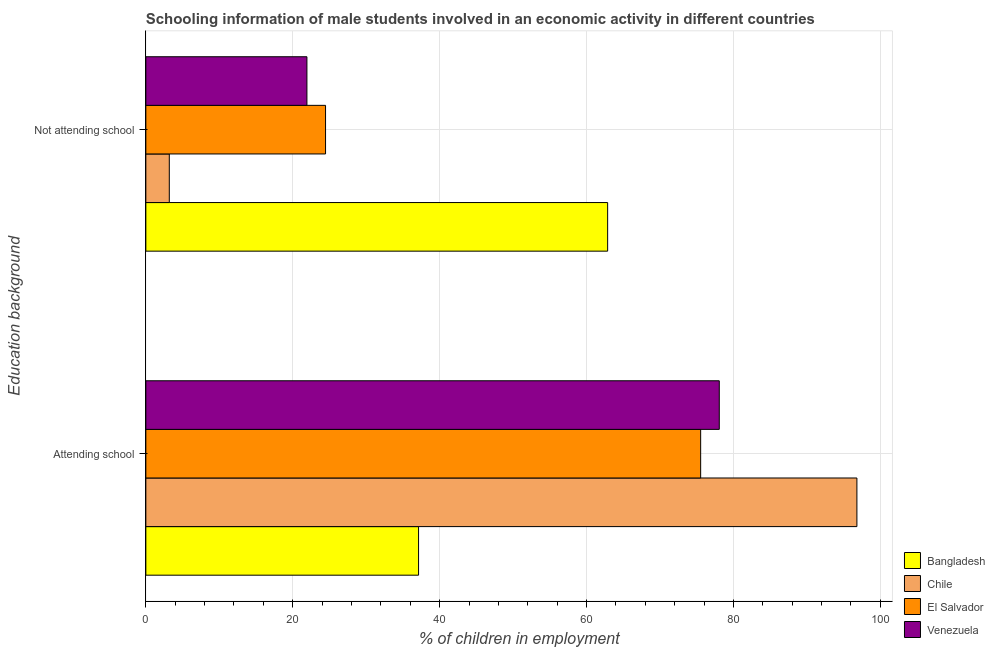How many different coloured bars are there?
Give a very brief answer. 4. How many groups of bars are there?
Ensure brevity in your answer.  2. How many bars are there on the 1st tick from the top?
Make the answer very short. 4. How many bars are there on the 1st tick from the bottom?
Give a very brief answer. 4. What is the label of the 1st group of bars from the top?
Give a very brief answer. Not attending school. What is the percentage of employed males who are attending school in Chile?
Give a very brief answer. 96.81. Across all countries, what is the maximum percentage of employed males who are not attending school?
Offer a terse response. 62.87. Across all countries, what is the minimum percentage of employed males who are attending school?
Provide a succinct answer. 37.13. In which country was the percentage of employed males who are attending school maximum?
Your answer should be very brief. Chile. What is the total percentage of employed males who are attending school in the graph?
Make the answer very short. 287.54. What is the difference between the percentage of employed males who are not attending school in Chile and that in Bangladesh?
Keep it short and to the point. -59.68. What is the difference between the percentage of employed males who are not attending school in Bangladesh and the percentage of employed males who are attending school in Chile?
Your answer should be very brief. -33.94. What is the average percentage of employed males who are attending school per country?
Keep it short and to the point. 71.88. What is the difference between the percentage of employed males who are attending school and percentage of employed males who are not attending school in El Salvador?
Provide a succinct answer. 51.07. In how many countries, is the percentage of employed males who are attending school greater than 36 %?
Your answer should be compact. 4. What is the ratio of the percentage of employed males who are attending school in Chile to that in Bangladesh?
Make the answer very short. 2.61. Is the percentage of employed males who are not attending school in Bangladesh less than that in Venezuela?
Provide a succinct answer. No. In how many countries, is the percentage of employed males who are attending school greater than the average percentage of employed males who are attending school taken over all countries?
Provide a succinct answer. 3. What does the 2nd bar from the top in Attending school represents?
Offer a terse response. El Salvador. Are the values on the major ticks of X-axis written in scientific E-notation?
Your answer should be compact. No. Where does the legend appear in the graph?
Provide a short and direct response. Bottom right. How are the legend labels stacked?
Your answer should be very brief. Vertical. What is the title of the graph?
Offer a terse response. Schooling information of male students involved in an economic activity in different countries. What is the label or title of the X-axis?
Make the answer very short. % of children in employment. What is the label or title of the Y-axis?
Offer a terse response. Education background. What is the % of children in employment in Bangladesh in Attending school?
Give a very brief answer. 37.13. What is the % of children in employment of Chile in Attending school?
Make the answer very short. 96.81. What is the % of children in employment in El Salvador in Attending school?
Ensure brevity in your answer.  75.53. What is the % of children in employment in Venezuela in Attending school?
Make the answer very short. 78.07. What is the % of children in employment of Bangladesh in Not attending school?
Your response must be concise. 62.87. What is the % of children in employment of Chile in Not attending school?
Make the answer very short. 3.19. What is the % of children in employment of El Salvador in Not attending school?
Provide a succinct answer. 24.47. What is the % of children in employment of Venezuela in Not attending school?
Your response must be concise. 21.93. Across all Education background, what is the maximum % of children in employment of Bangladesh?
Your answer should be compact. 62.87. Across all Education background, what is the maximum % of children in employment of Chile?
Provide a succinct answer. 96.81. Across all Education background, what is the maximum % of children in employment in El Salvador?
Your answer should be compact. 75.53. Across all Education background, what is the maximum % of children in employment of Venezuela?
Offer a terse response. 78.07. Across all Education background, what is the minimum % of children in employment of Bangladesh?
Your answer should be compact. 37.13. Across all Education background, what is the minimum % of children in employment in Chile?
Provide a succinct answer. 3.19. Across all Education background, what is the minimum % of children in employment of El Salvador?
Keep it short and to the point. 24.47. Across all Education background, what is the minimum % of children in employment of Venezuela?
Your answer should be compact. 21.93. What is the total % of children in employment in Bangladesh in the graph?
Keep it short and to the point. 100. What is the difference between the % of children in employment in Bangladesh in Attending school and that in Not attending school?
Your answer should be very brief. -25.74. What is the difference between the % of children in employment in Chile in Attending school and that in Not attending school?
Provide a short and direct response. 93.61. What is the difference between the % of children in employment of El Salvador in Attending school and that in Not attending school?
Offer a terse response. 51.07. What is the difference between the % of children in employment in Venezuela in Attending school and that in Not attending school?
Keep it short and to the point. 56.14. What is the difference between the % of children in employment in Bangladesh in Attending school and the % of children in employment in Chile in Not attending school?
Your answer should be very brief. 33.94. What is the difference between the % of children in employment of Bangladesh in Attending school and the % of children in employment of El Salvador in Not attending school?
Offer a very short reply. 12.66. What is the difference between the % of children in employment in Bangladesh in Attending school and the % of children in employment in Venezuela in Not attending school?
Make the answer very short. 15.2. What is the difference between the % of children in employment in Chile in Attending school and the % of children in employment in El Salvador in Not attending school?
Provide a short and direct response. 72.34. What is the difference between the % of children in employment of Chile in Attending school and the % of children in employment of Venezuela in Not attending school?
Provide a short and direct response. 74.88. What is the difference between the % of children in employment in El Salvador in Attending school and the % of children in employment in Venezuela in Not attending school?
Make the answer very short. 53.6. What is the average % of children in employment of Bangladesh per Education background?
Offer a very short reply. 50. What is the average % of children in employment of Chile per Education background?
Your answer should be very brief. 50. What is the average % of children in employment of El Salvador per Education background?
Give a very brief answer. 50. What is the difference between the % of children in employment in Bangladesh and % of children in employment in Chile in Attending school?
Your answer should be very brief. -59.68. What is the difference between the % of children in employment of Bangladesh and % of children in employment of El Salvador in Attending school?
Keep it short and to the point. -38.4. What is the difference between the % of children in employment of Bangladesh and % of children in employment of Venezuela in Attending school?
Give a very brief answer. -40.94. What is the difference between the % of children in employment in Chile and % of children in employment in El Salvador in Attending school?
Offer a very short reply. 21.27. What is the difference between the % of children in employment in Chile and % of children in employment in Venezuela in Attending school?
Give a very brief answer. 18.74. What is the difference between the % of children in employment of El Salvador and % of children in employment of Venezuela in Attending school?
Keep it short and to the point. -2.54. What is the difference between the % of children in employment in Bangladesh and % of children in employment in Chile in Not attending school?
Make the answer very short. 59.68. What is the difference between the % of children in employment of Bangladesh and % of children in employment of El Salvador in Not attending school?
Your answer should be very brief. 38.4. What is the difference between the % of children in employment in Bangladesh and % of children in employment in Venezuela in Not attending school?
Keep it short and to the point. 40.94. What is the difference between the % of children in employment of Chile and % of children in employment of El Salvador in Not attending school?
Provide a succinct answer. -21.27. What is the difference between the % of children in employment of Chile and % of children in employment of Venezuela in Not attending school?
Your answer should be compact. -18.74. What is the difference between the % of children in employment in El Salvador and % of children in employment in Venezuela in Not attending school?
Provide a succinct answer. 2.54. What is the ratio of the % of children in employment of Bangladesh in Attending school to that in Not attending school?
Offer a terse response. 0.59. What is the ratio of the % of children in employment of Chile in Attending school to that in Not attending school?
Your response must be concise. 30.31. What is the ratio of the % of children in employment in El Salvador in Attending school to that in Not attending school?
Offer a terse response. 3.09. What is the ratio of the % of children in employment in Venezuela in Attending school to that in Not attending school?
Give a very brief answer. 3.56. What is the difference between the highest and the second highest % of children in employment of Bangladesh?
Your answer should be compact. 25.74. What is the difference between the highest and the second highest % of children in employment in Chile?
Give a very brief answer. 93.61. What is the difference between the highest and the second highest % of children in employment in El Salvador?
Your answer should be very brief. 51.07. What is the difference between the highest and the second highest % of children in employment of Venezuela?
Provide a succinct answer. 56.14. What is the difference between the highest and the lowest % of children in employment of Bangladesh?
Offer a very short reply. 25.74. What is the difference between the highest and the lowest % of children in employment in Chile?
Your answer should be very brief. 93.61. What is the difference between the highest and the lowest % of children in employment in El Salvador?
Make the answer very short. 51.07. What is the difference between the highest and the lowest % of children in employment in Venezuela?
Keep it short and to the point. 56.14. 